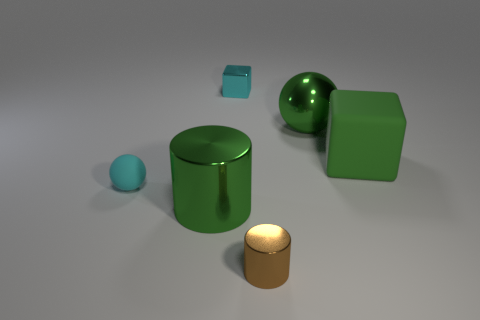Add 6 small rubber blocks. How many small rubber blocks exist? 6 Add 2 green rubber things. How many objects exist? 8 Subtract 0 cyan cylinders. How many objects are left? 6 Subtract all blocks. How many objects are left? 4 Subtract 1 balls. How many balls are left? 1 Subtract all red cubes. Subtract all brown cylinders. How many cubes are left? 2 Subtract all cyan spheres. How many green cubes are left? 1 Subtract all metallic cylinders. Subtract all tiny brown metal things. How many objects are left? 3 Add 6 brown things. How many brown things are left? 7 